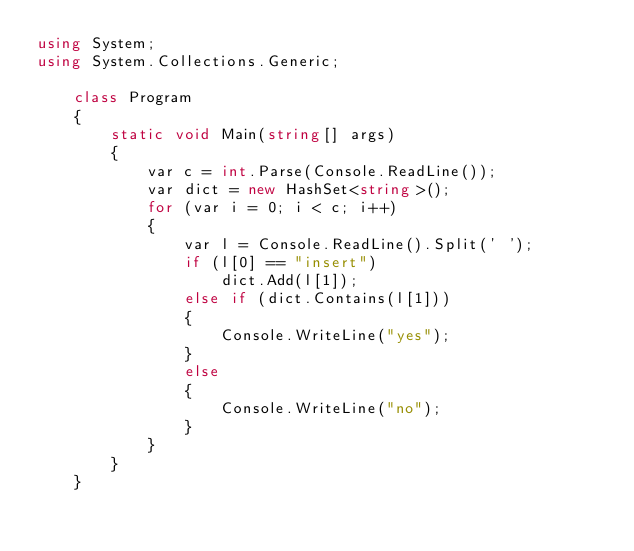<code> <loc_0><loc_0><loc_500><loc_500><_C#_>using System;
using System.Collections.Generic;

    class Program
    {
        static void Main(string[] args)
        {
            var c = int.Parse(Console.ReadLine());
            var dict = new HashSet<string>();
            for (var i = 0; i < c; i++)
            {
                var l = Console.ReadLine().Split(' ');
                if (l[0] == "insert")
                    dict.Add(l[1]);
                else if (dict.Contains(l[1]))
                {
                    Console.WriteLine("yes");
                }
                else
                {
                    Console.WriteLine("no");
                }
            }
        }
    }
</code> 